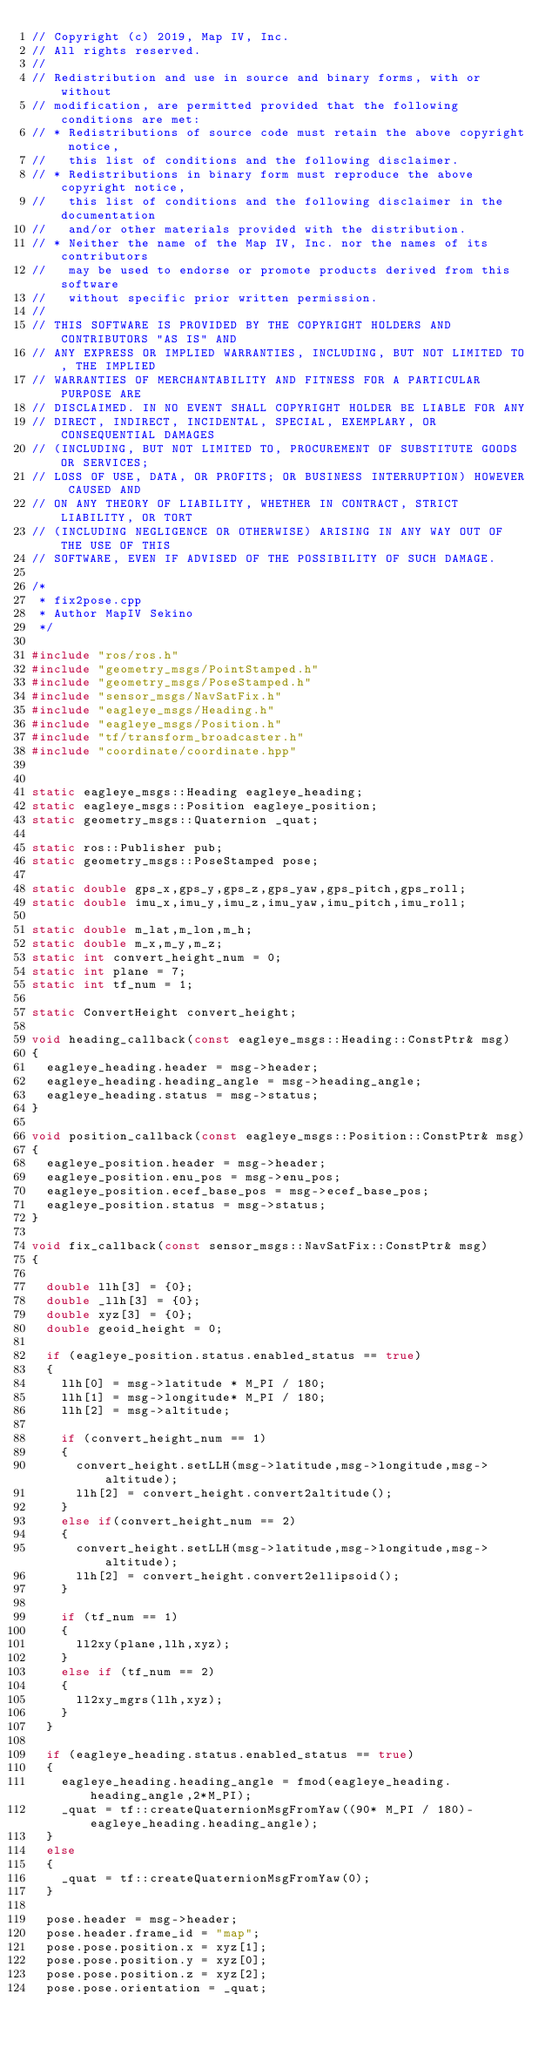Convert code to text. <code><loc_0><loc_0><loc_500><loc_500><_C++_>// Copyright (c) 2019, Map IV, Inc.
// All rights reserved.
//
// Redistribution and use in source and binary forms, with or without
// modification, are permitted provided that the following conditions are met:
// * Redistributions of source code must retain the above copyright notice,
//   this list of conditions and the following disclaimer.
// * Redistributions in binary form must reproduce the above copyright notice,
//   this list of conditions and the following disclaimer in the documentation
//   and/or other materials provided with the distribution.
// * Neither the name of the Map IV, Inc. nor the names of its contributors
//   may be used to endorse or promote products derived from this software
//   without specific prior written permission.
//
// THIS SOFTWARE IS PROVIDED BY THE COPYRIGHT HOLDERS AND CONTRIBUTORS "AS IS" AND
// ANY EXPRESS OR IMPLIED WARRANTIES, INCLUDING, BUT NOT LIMITED TO, THE IMPLIED
// WARRANTIES OF MERCHANTABILITY AND FITNESS FOR A PARTICULAR PURPOSE ARE
// DISCLAIMED. IN NO EVENT SHALL COPYRIGHT HOLDER BE LIABLE FOR ANY
// DIRECT, INDIRECT, INCIDENTAL, SPECIAL, EXEMPLARY, OR CONSEQUENTIAL DAMAGES
// (INCLUDING, BUT NOT LIMITED TO, PROCUREMENT OF SUBSTITUTE GOODS OR SERVICES;
// LOSS OF USE, DATA, OR PROFITS; OR BUSINESS INTERRUPTION) HOWEVER CAUSED AND
// ON ANY THEORY OF LIABILITY, WHETHER IN CONTRACT, STRICT LIABILITY, OR TORT
// (INCLUDING NEGLIGENCE OR OTHERWISE) ARISING IN ANY WAY OUT OF THE USE OF THIS
// SOFTWARE, EVEN IF ADVISED OF THE POSSIBILITY OF SUCH DAMAGE.

/*
 * fix2pose.cpp
 * Author MapIV Sekino
 */

#include "ros/ros.h"
#include "geometry_msgs/PointStamped.h"
#include "geometry_msgs/PoseStamped.h"
#include "sensor_msgs/NavSatFix.h"
#include "eagleye_msgs/Heading.h"
#include "eagleye_msgs/Position.h"
#include "tf/transform_broadcaster.h"
#include "coordinate/coordinate.hpp"


static eagleye_msgs::Heading eagleye_heading;
static eagleye_msgs::Position eagleye_position;
static geometry_msgs::Quaternion _quat;

static ros::Publisher pub;
static geometry_msgs::PoseStamped pose;

static double gps_x,gps_y,gps_z,gps_yaw,gps_pitch,gps_roll;
static double imu_x,imu_y,imu_z,imu_yaw,imu_pitch,imu_roll;

static double m_lat,m_lon,m_h;
static double m_x,m_y,m_z;
static int convert_height_num = 0;
static int plane = 7;
static int tf_num = 1;

static ConvertHeight convert_height;

void heading_callback(const eagleye_msgs::Heading::ConstPtr& msg)
{
  eagleye_heading.header = msg->header;
  eagleye_heading.heading_angle = msg->heading_angle;
  eagleye_heading.status = msg->status;
}

void position_callback(const eagleye_msgs::Position::ConstPtr& msg)
{
  eagleye_position.header = msg->header;
  eagleye_position.enu_pos = msg->enu_pos;
  eagleye_position.ecef_base_pos = msg->ecef_base_pos;
  eagleye_position.status = msg->status;
}

void fix_callback(const sensor_msgs::NavSatFix::ConstPtr& msg)
{

  double llh[3] = {0};
  double _llh[3] = {0};
  double xyz[3] = {0};
  double geoid_height = 0;

  if (eagleye_position.status.enabled_status == true)
  {
    llh[0] = msg->latitude * M_PI / 180;
    llh[1] = msg->longitude* M_PI / 180;
    llh[2] = msg->altitude;

    if (convert_height_num == 1)
    {
      convert_height.setLLH(msg->latitude,msg->longitude,msg->altitude);
      llh[2] = convert_height.convert2altitude();
    }
    else if(convert_height_num == 2)
    {
      convert_height.setLLH(msg->latitude,msg->longitude,msg->altitude);
      llh[2] = convert_height.convert2ellipsoid();
    }

    if (tf_num == 1)
    {
      ll2xy(plane,llh,xyz);
    }
    else if (tf_num == 2)
    {
      ll2xy_mgrs(llh,xyz);
    }
  }

  if (eagleye_heading.status.enabled_status == true)
  {
    eagleye_heading.heading_angle = fmod(eagleye_heading.heading_angle,2*M_PI);
    _quat = tf::createQuaternionMsgFromYaw((90* M_PI / 180)-eagleye_heading.heading_angle);
  }
  else
  {
    _quat = tf::createQuaternionMsgFromYaw(0);
  }

  pose.header = msg->header;
  pose.header.frame_id = "map";
  pose.pose.position.x = xyz[1];
  pose.pose.position.y = xyz[0];
  pose.pose.position.z = xyz[2];
  pose.pose.orientation = _quat;</code> 